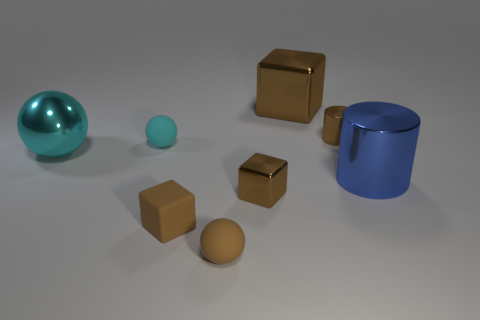Add 1 tiny red shiny blocks. How many objects exist? 9 Subtract all cylinders. How many objects are left? 6 Add 4 small brown spheres. How many small brown spheres are left? 5 Add 1 brown shiny cylinders. How many brown shiny cylinders exist? 2 Subtract 0 green cylinders. How many objects are left? 8 Subtract all cylinders. Subtract all tiny brown matte spheres. How many objects are left? 5 